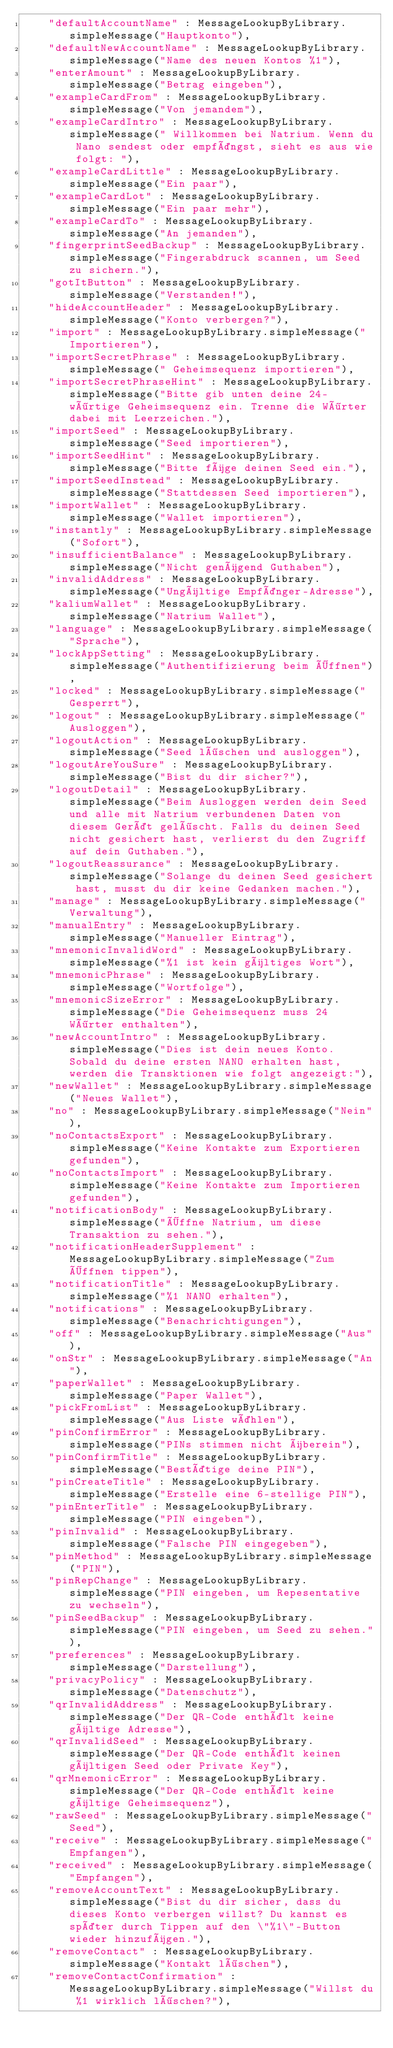<code> <loc_0><loc_0><loc_500><loc_500><_Dart_>    "defaultAccountName" : MessageLookupByLibrary.simpleMessage("Hauptkonto"),
    "defaultNewAccountName" : MessageLookupByLibrary.simpleMessage("Name des neuen Kontos %1"),
    "enterAmount" : MessageLookupByLibrary.simpleMessage("Betrag eingeben"),
    "exampleCardFrom" : MessageLookupByLibrary.simpleMessage("Von jemandem"),
    "exampleCardIntro" : MessageLookupByLibrary.simpleMessage(" Willkommen bei Natrium. Wenn du Nano sendest oder empfängst, sieht es aus wie folgt: "),
    "exampleCardLittle" : MessageLookupByLibrary.simpleMessage("Ein paar"),
    "exampleCardLot" : MessageLookupByLibrary.simpleMessage("Ein paar mehr"),
    "exampleCardTo" : MessageLookupByLibrary.simpleMessage("An jemanden"),
    "fingerprintSeedBackup" : MessageLookupByLibrary.simpleMessage("Fingerabdruck scannen, um Seed zu sichern."),
    "gotItButton" : MessageLookupByLibrary.simpleMessage("Verstanden!"),
    "hideAccountHeader" : MessageLookupByLibrary.simpleMessage("Konto verbergen?"),
    "import" : MessageLookupByLibrary.simpleMessage("Importieren"),
    "importSecretPhrase" : MessageLookupByLibrary.simpleMessage(" Geheimsequenz importieren"),
    "importSecretPhraseHint" : MessageLookupByLibrary.simpleMessage("Bitte gib unten deine 24-wörtige Geheimsequenz ein. Trenne die Wörter dabei mit Leerzeichen."),
    "importSeed" : MessageLookupByLibrary.simpleMessage("Seed importieren"),
    "importSeedHint" : MessageLookupByLibrary.simpleMessage("Bitte füge deinen Seed ein."),
    "importSeedInstead" : MessageLookupByLibrary.simpleMessage("Stattdessen Seed importieren"),
    "importWallet" : MessageLookupByLibrary.simpleMessage("Wallet importieren"),
    "instantly" : MessageLookupByLibrary.simpleMessage("Sofort"),
    "insufficientBalance" : MessageLookupByLibrary.simpleMessage("Nicht genügend Guthaben"),
    "invalidAddress" : MessageLookupByLibrary.simpleMessage("Ungültige Empfänger-Adresse"),
    "kaliumWallet" : MessageLookupByLibrary.simpleMessage("Natrium Wallet"),
    "language" : MessageLookupByLibrary.simpleMessage("Sprache"),
    "lockAppSetting" : MessageLookupByLibrary.simpleMessage("Authentifizierung beim Öffnen"),
    "locked" : MessageLookupByLibrary.simpleMessage("Gesperrt"),
    "logout" : MessageLookupByLibrary.simpleMessage("Ausloggen"),
    "logoutAction" : MessageLookupByLibrary.simpleMessage("Seed löschen und ausloggen"),
    "logoutAreYouSure" : MessageLookupByLibrary.simpleMessage("Bist du dir sicher?"),
    "logoutDetail" : MessageLookupByLibrary.simpleMessage("Beim Ausloggen werden dein Seed und alle mit Natrium verbundenen Daten von diesem Gerät gelöscht. Falls du deinen Seed nicht gesichert hast, verlierst du den Zugriff auf dein Guthaben."),
    "logoutReassurance" : MessageLookupByLibrary.simpleMessage("Solange du deinen Seed gesichert hast, musst du dir keine Gedanken machen."),
    "manage" : MessageLookupByLibrary.simpleMessage("Verwaltung"),
    "manualEntry" : MessageLookupByLibrary.simpleMessage("Manueller Eintrag"),
    "mnemonicInvalidWord" : MessageLookupByLibrary.simpleMessage("%1 ist kein gültiges Wort"),
    "mnemonicPhrase" : MessageLookupByLibrary.simpleMessage("Wortfolge"),
    "mnemonicSizeError" : MessageLookupByLibrary.simpleMessage("Die Geheimsequenz muss 24 Wörter enthalten"),
    "newAccountIntro" : MessageLookupByLibrary.simpleMessage("Dies ist dein neues Konto. Sobald du deine ersten NANO erhalten hast, werden die Transktionen wie folgt angezeigt:"),
    "newWallet" : MessageLookupByLibrary.simpleMessage("Neues Wallet"),
    "no" : MessageLookupByLibrary.simpleMessage("Nein"),
    "noContactsExport" : MessageLookupByLibrary.simpleMessage("Keine Kontakte zum Exportieren gefunden"),
    "noContactsImport" : MessageLookupByLibrary.simpleMessage("Keine Kontakte zum Importieren gefunden"),
    "notificationBody" : MessageLookupByLibrary.simpleMessage("Öffne Natrium, um diese Transaktion zu sehen."),
    "notificationHeaderSupplement" : MessageLookupByLibrary.simpleMessage("Zum Öffnen tippen"),
    "notificationTitle" : MessageLookupByLibrary.simpleMessage("%1 NANO erhalten"),
    "notifications" : MessageLookupByLibrary.simpleMessage("Benachrichtigungen"),
    "off" : MessageLookupByLibrary.simpleMessage("Aus"),
    "onStr" : MessageLookupByLibrary.simpleMessage("An"),
    "paperWallet" : MessageLookupByLibrary.simpleMessage("Paper Wallet"),
    "pickFromList" : MessageLookupByLibrary.simpleMessage("Aus Liste wählen"),
    "pinConfirmError" : MessageLookupByLibrary.simpleMessage("PINs stimmen nicht überein"),
    "pinConfirmTitle" : MessageLookupByLibrary.simpleMessage("Bestätige deine PIN"),
    "pinCreateTitle" : MessageLookupByLibrary.simpleMessage("Erstelle eine 6-stellige PIN"),
    "pinEnterTitle" : MessageLookupByLibrary.simpleMessage("PIN eingeben"),
    "pinInvalid" : MessageLookupByLibrary.simpleMessage("Falsche PIN eingegeben"),
    "pinMethod" : MessageLookupByLibrary.simpleMessage("PIN"),
    "pinRepChange" : MessageLookupByLibrary.simpleMessage("PIN eingeben, um Repesentative zu wechseln"),
    "pinSeedBackup" : MessageLookupByLibrary.simpleMessage("PIN eingeben, um Seed zu sehen."),
    "preferences" : MessageLookupByLibrary.simpleMessage("Darstellung"),
    "privacyPolicy" : MessageLookupByLibrary.simpleMessage("Datenschutz"),
    "qrInvalidAddress" : MessageLookupByLibrary.simpleMessage("Der QR-Code enthält keine gültige Adresse"),
    "qrInvalidSeed" : MessageLookupByLibrary.simpleMessage("Der QR-Code enthält keinen gültigen Seed oder Private Key"),
    "qrMnemonicError" : MessageLookupByLibrary.simpleMessage("Der QR-Code enthält keine gültige Geheimsequenz"),
    "rawSeed" : MessageLookupByLibrary.simpleMessage("Seed"),
    "receive" : MessageLookupByLibrary.simpleMessage("Empfangen"),
    "received" : MessageLookupByLibrary.simpleMessage("Empfangen"),
    "removeAccountText" : MessageLookupByLibrary.simpleMessage("Bist du dir sicher, dass du dieses Konto verbergen willst? Du kannst es später durch Tippen auf den \"%1\"-Button wieder hinzufügen."),
    "removeContact" : MessageLookupByLibrary.simpleMessage("Kontakt löschen"),
    "removeContactConfirmation" : MessageLookupByLibrary.simpleMessage("Willst du %1 wirklich löschen?"),</code> 